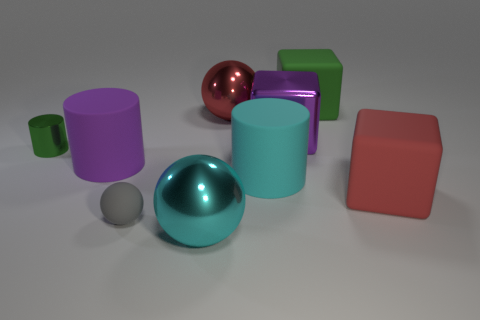There is a matte thing that is on the left side of the green rubber cube and right of the cyan metallic sphere; how big is it? The object in question, which appears matte and is situated between the green rubber cube on its right and the cyan metallic sphere on its left, is relatively small in comparison to the surrounding objects. It is of a size that is consistent with the smaller objects in the scene, possibly a little larger than the small grey sphere near the center. 